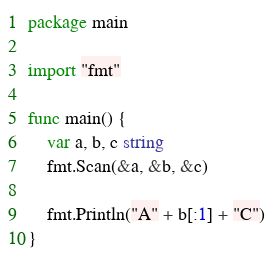Convert code to text. <code><loc_0><loc_0><loc_500><loc_500><_Go_>package main

import "fmt"

func main() {
	var a, b, c string
	fmt.Scan(&a, &b, &c)

	fmt.Println("A" + b[:1] + "C")
}
</code> 